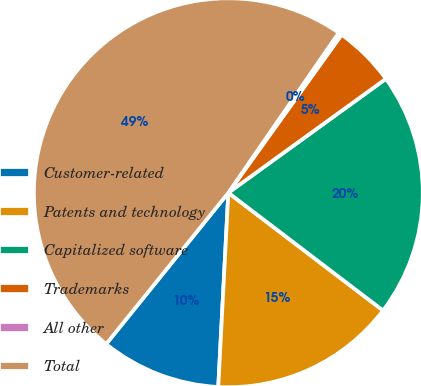<chart> <loc_0><loc_0><loc_500><loc_500><pie_chart><fcel>Customer-related<fcel>Patents and technology<fcel>Capitalized software<fcel>Trademarks<fcel>All other<fcel>Total<nl><fcel>9.99%<fcel>15.47%<fcel>20.32%<fcel>5.14%<fcel>0.28%<fcel>48.8%<nl></chart> 